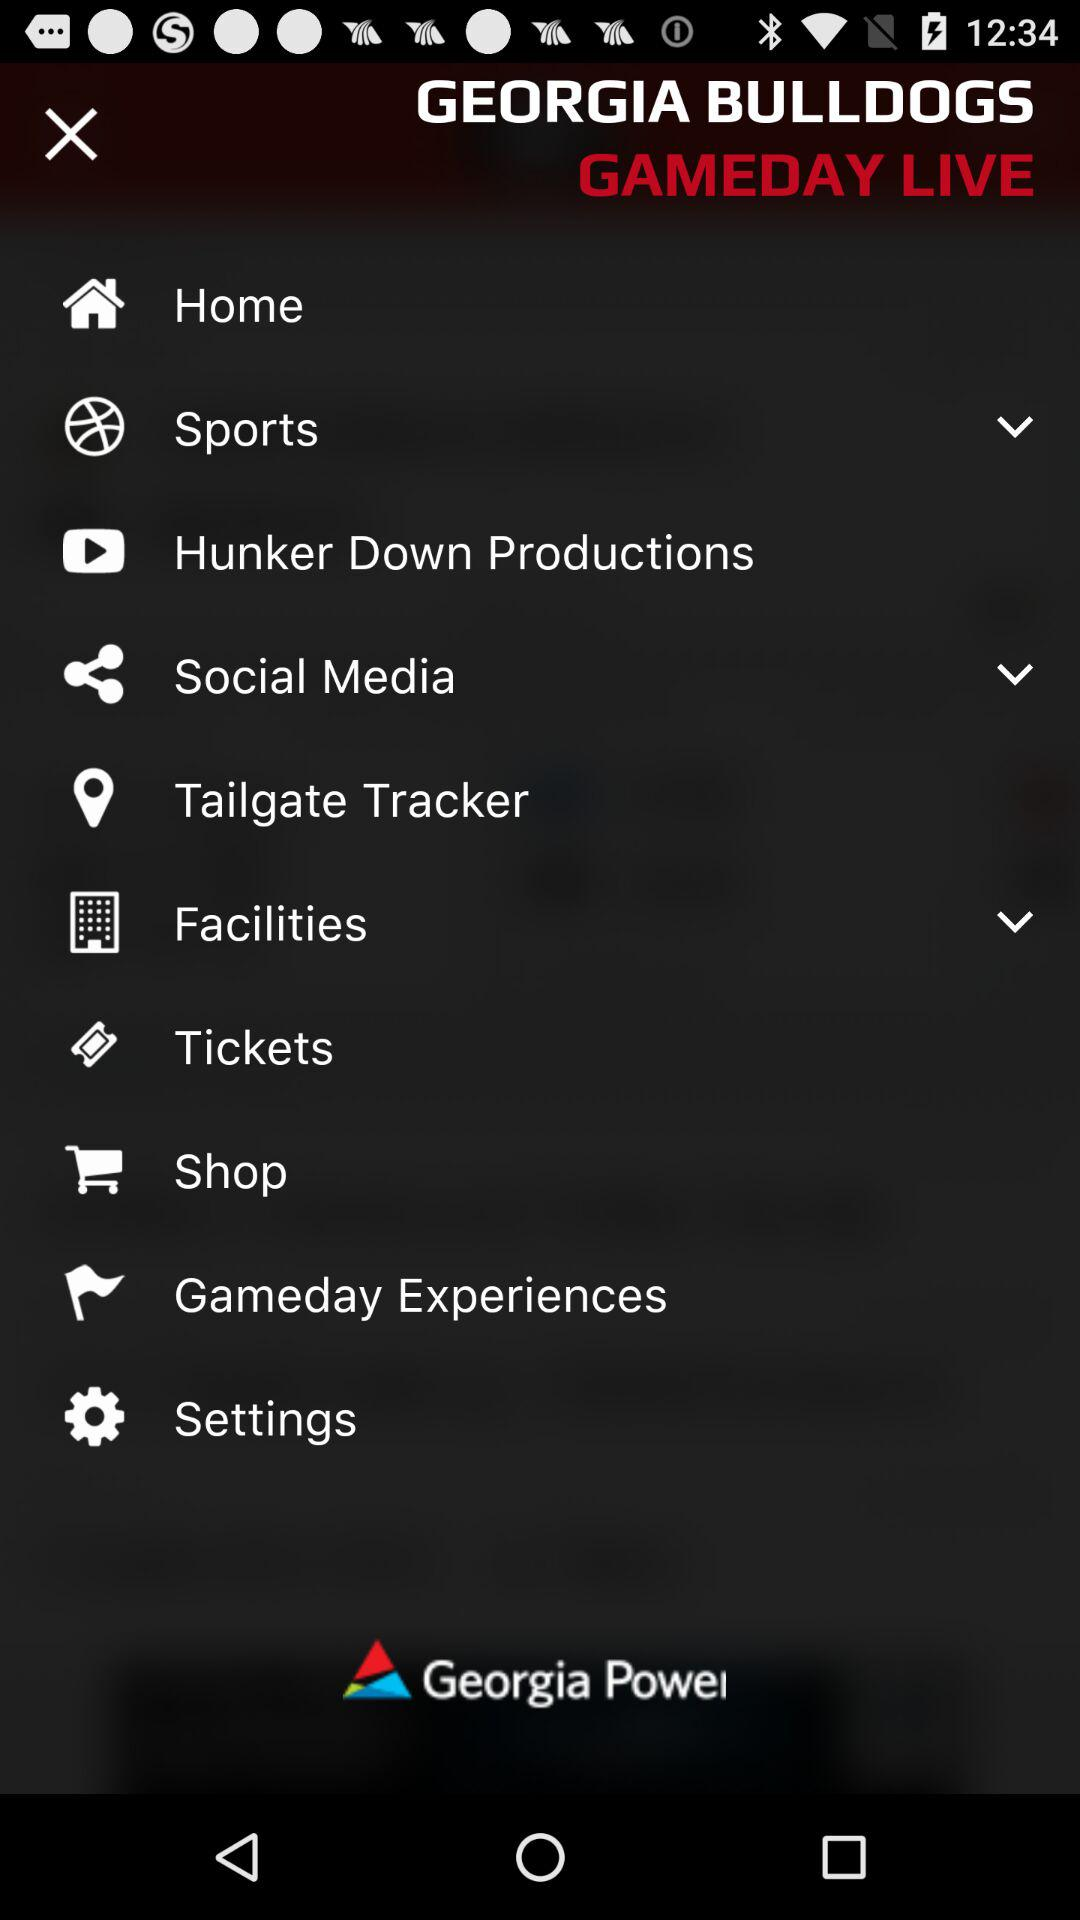What is the name of the application? The name of the application is "GEORGIA BULLDOGS". 